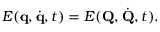<formula> <loc_0><loc_0><loc_500><loc_500>E ( q , { \dot { q } } , t ) = E ( Q , { \dot { Q } } , t ) .</formula> 